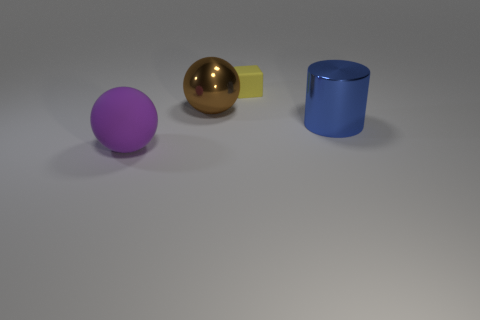Add 3 tiny brown things. How many objects exist? 7 Subtract all cubes. How many objects are left? 3 Subtract all big shiny cylinders. Subtract all tiny yellow matte objects. How many objects are left? 2 Add 2 blue metallic things. How many blue metallic things are left? 3 Add 3 tiny yellow things. How many tiny yellow things exist? 4 Subtract 0 red spheres. How many objects are left? 4 